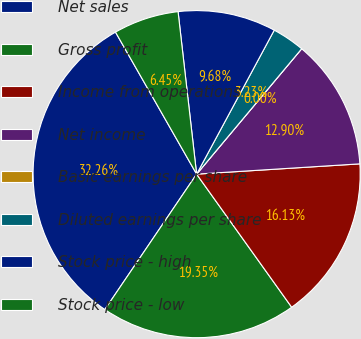<chart> <loc_0><loc_0><loc_500><loc_500><pie_chart><fcel>Net sales<fcel>Gross profit<fcel>Income from operations<fcel>Net income<fcel>Basic earnings per share<fcel>Diluted earnings per share<fcel>Stock price - high<fcel>Stock price - low<nl><fcel>32.26%<fcel>19.35%<fcel>16.13%<fcel>12.9%<fcel>0.0%<fcel>3.23%<fcel>9.68%<fcel>6.45%<nl></chart> 